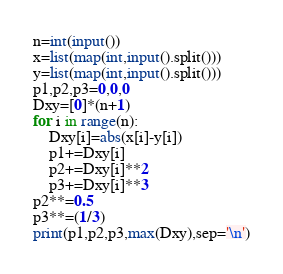Convert code to text. <code><loc_0><loc_0><loc_500><loc_500><_Python_>n=int(input())
x=list(map(int,input().split()))
y=list(map(int,input().split()))
p1,p2,p3=0,0,0
Dxy=[0]*(n+1)
for i in range(n):
    Dxy[i]=abs(x[i]-y[i])
    p1+=Dxy[i]
    p2+=Dxy[i]**2
    p3+=Dxy[i]**3
p2**=0.5
p3**=(1/3)
print(p1,p2,p3,max(Dxy),sep='\n')
</code> 